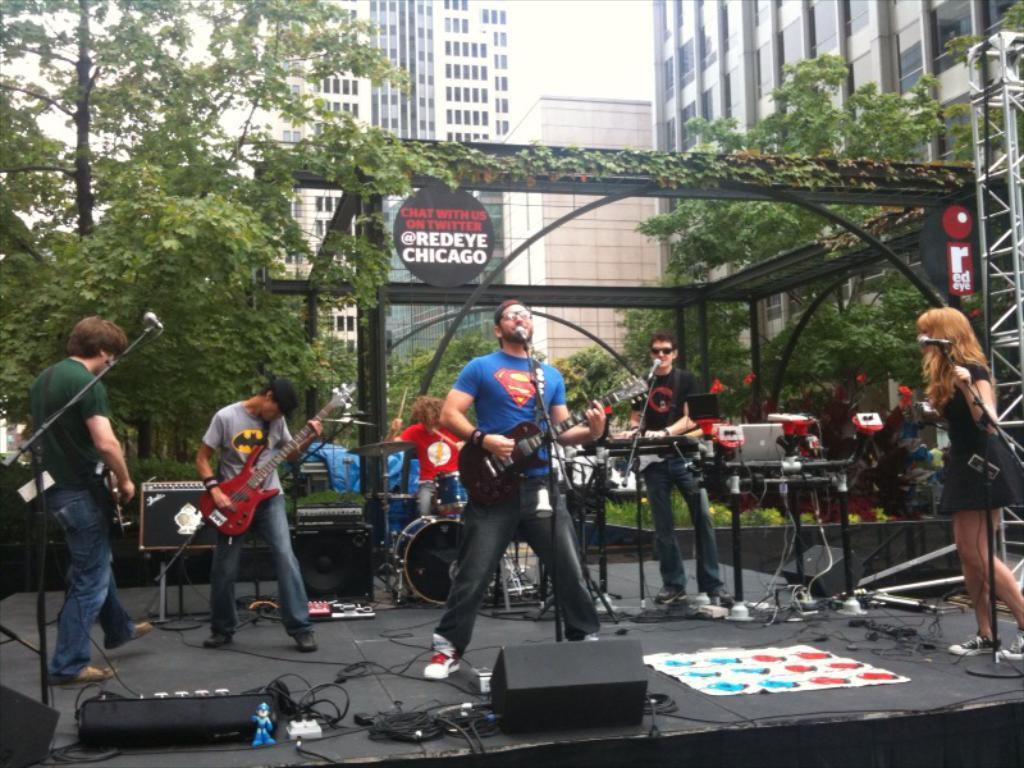Please provide a concise description of this image. In the middle of the image few people are playing some musical instruments. Bottom right side of the image a woman is standing and holding a microphone. Behind them there are some trees and buildings. Bottom of the image there are some electronic devices and wires. 